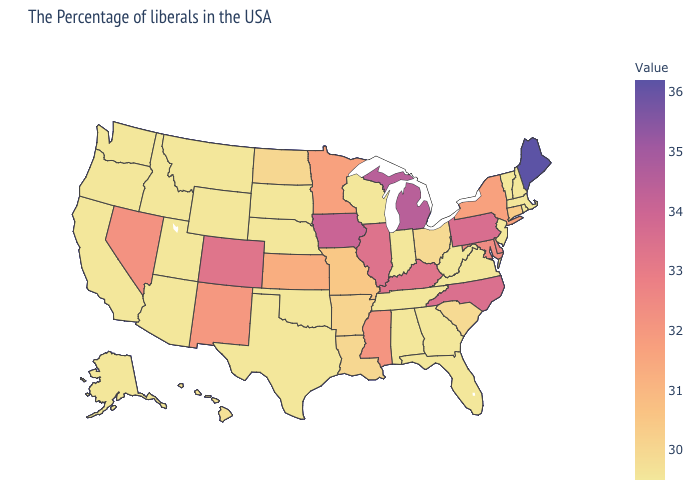Does Connecticut have the highest value in the USA?
Keep it brief. No. Does the map have missing data?
Concise answer only. No. Among the states that border Minnesota , which have the highest value?
Be succinct. Iowa. Among the states that border Massachusetts , does Rhode Island have the highest value?
Be succinct. No. Does Maine have the highest value in the USA?
Short answer required. Yes. 